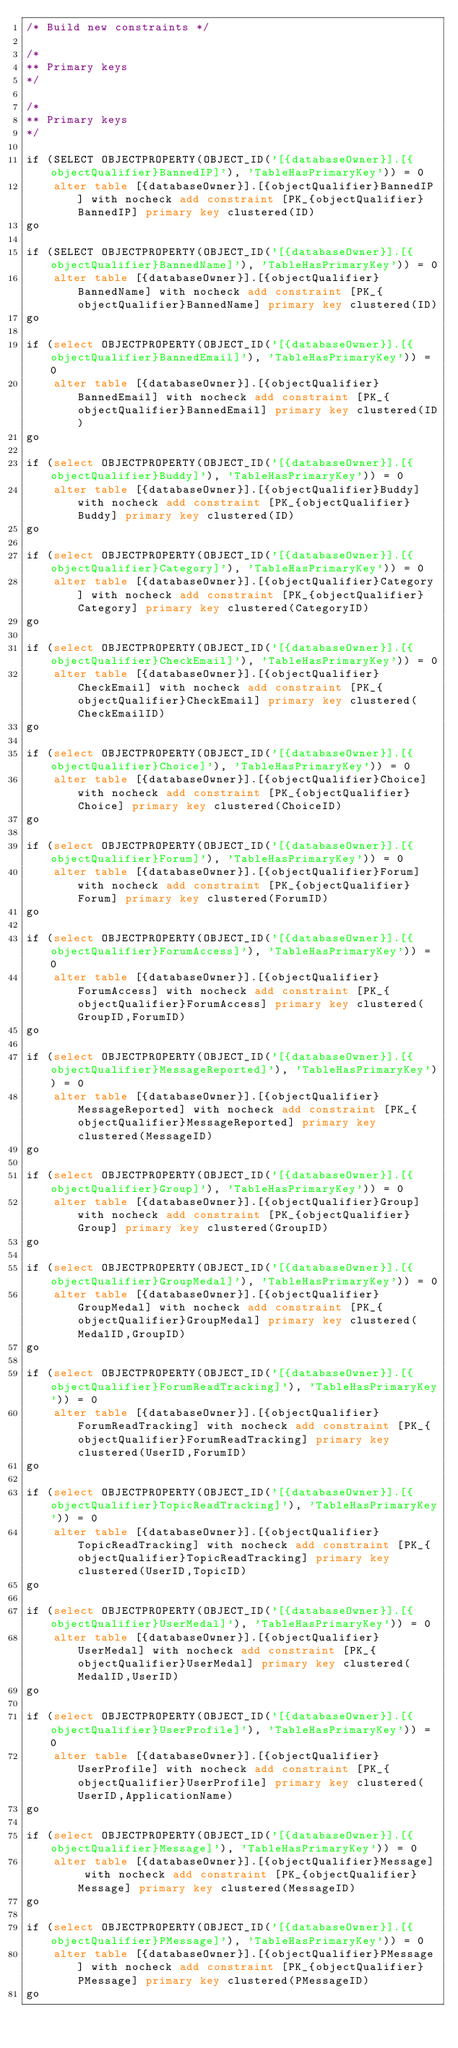Convert code to text. <code><loc_0><loc_0><loc_500><loc_500><_SQL_>/* Build new constraints */

/*
** Primary keys
*/

/*
** Primary keys
*/

if (SELECT OBJECTPROPERTY(OBJECT_ID('[{databaseOwner}].[{objectQualifier}BannedIP]'), 'TableHasPrimaryKey')) = 0
	alter table [{databaseOwner}].[{objectQualifier}BannedIP] with nocheck add constraint [PK_{objectQualifier}BannedIP] primary key clustered(ID)
go

if (SELECT OBJECTPROPERTY(OBJECT_ID('[{databaseOwner}].[{objectQualifier}BannedName]'), 'TableHasPrimaryKey')) = 0
	alter table [{databaseOwner}].[{objectQualifier}BannedName] with nocheck add constraint [PK_{objectQualifier}BannedName] primary key clustered(ID)
go

if (select OBJECTPROPERTY(OBJECT_ID('[{databaseOwner}].[{objectQualifier}BannedEmail]'), 'TableHasPrimaryKey')) = 0
	alter table [{databaseOwner}].[{objectQualifier}BannedEmail] with nocheck add constraint [PK_{objectQualifier}BannedEmail] primary key clustered(ID)
go

if (select OBJECTPROPERTY(OBJECT_ID('[{databaseOwner}].[{objectQualifier}Buddy]'), 'TableHasPrimaryKey')) = 0
	alter table [{databaseOwner}].[{objectQualifier}Buddy] with nocheck add constraint [PK_{objectQualifier}Buddy] primary key clustered(ID)   
go

if (select OBJECTPROPERTY(OBJECT_ID('[{databaseOwner}].[{objectQualifier}Category]'), 'TableHasPrimaryKey')) = 0
	alter table [{databaseOwner}].[{objectQualifier}Category] with nocheck add constraint [PK_{objectQualifier}Category] primary key clustered(CategoryID)   
go

if (select OBJECTPROPERTY(OBJECT_ID('[{databaseOwner}].[{objectQualifier}CheckEmail]'), 'TableHasPrimaryKey')) = 0
	alter table [{databaseOwner}].[{objectQualifier}CheckEmail] with nocheck add constraint [PK_{objectQualifier}CheckEmail] primary key clustered(CheckEmailID)   
go

if (select OBJECTPROPERTY(OBJECT_ID('[{databaseOwner}].[{objectQualifier}Choice]'), 'TableHasPrimaryKey')) = 0
	alter table [{databaseOwner}].[{objectQualifier}Choice] with nocheck add constraint [PK_{objectQualifier}Choice] primary key clustered(ChoiceID)   
go

if (select OBJECTPROPERTY(OBJECT_ID('[{databaseOwner}].[{objectQualifier}Forum]'), 'TableHasPrimaryKey')) = 0
	alter table [{databaseOwner}].[{objectQualifier}Forum] with nocheck add constraint [PK_{objectQualifier}Forum] primary key clustered(ForumID)   
go

if (select OBJECTPROPERTY(OBJECT_ID('[{databaseOwner}].[{objectQualifier}ForumAccess]'), 'TableHasPrimaryKey')) = 0
	alter table [{databaseOwner}].[{objectQualifier}ForumAccess] with nocheck add constraint [PK_{objectQualifier}ForumAccess] primary key clustered(GroupID,ForumID)   
go

if (select OBJECTPROPERTY(OBJECT_ID('[{databaseOwner}].[{objectQualifier}MessageReported]'), 'TableHasPrimaryKey')) = 0
	alter table [{databaseOwner}].[{objectQualifier}MessageReported] with nocheck add constraint [PK_{objectQualifier}MessageReported] primary key clustered(MessageID)   
go

if (select OBJECTPROPERTY(OBJECT_ID('[{databaseOwner}].[{objectQualifier}Group]'), 'TableHasPrimaryKey')) = 0
	alter table [{databaseOwner}].[{objectQualifier}Group] with nocheck add constraint [PK_{objectQualifier}Group] primary key clustered(GroupID)   
go

if (select OBJECTPROPERTY(OBJECT_ID('[{databaseOwner}].[{objectQualifier}GroupMedal]'), 'TableHasPrimaryKey')) = 0
	alter table [{databaseOwner}].[{objectQualifier}GroupMedal] with nocheck add constraint [PK_{objectQualifier}GroupMedal] primary key clustered(MedalID,GroupID)   
go

if (select OBJECTPROPERTY(OBJECT_ID('[{databaseOwner}].[{objectQualifier}ForumReadTracking]'), 'TableHasPrimaryKey')) = 0
	alter table [{databaseOwner}].[{objectQualifier}ForumReadTracking] with nocheck add constraint [PK_{objectQualifier}ForumReadTracking] primary key clustered(UserID,ForumID)   
go

if (select OBJECTPROPERTY(OBJECT_ID('[{databaseOwner}].[{objectQualifier}TopicReadTracking]'), 'TableHasPrimaryKey')) = 0
	alter table [{databaseOwner}].[{objectQualifier}TopicReadTracking] with nocheck add constraint [PK_{objectQualifier}TopicReadTracking] primary key clustered(UserID,TopicID)   
go

if (select OBJECTPROPERTY(OBJECT_ID('[{databaseOwner}].[{objectQualifier}UserMedal]'), 'TableHasPrimaryKey')) = 0
	alter table [{databaseOwner}].[{objectQualifier}UserMedal] with nocheck add constraint [PK_{objectQualifier}UserMedal] primary key clustered(MedalID,UserID)   
go

if (select OBJECTPROPERTY(OBJECT_ID('[{databaseOwner}].[{objectQualifier}UserProfile]'), 'TableHasPrimaryKey')) = 0
	alter table [{databaseOwner}].[{objectQualifier}UserProfile] with nocheck add constraint [PK_{objectQualifier}UserProfile] primary key clustered(UserID,ApplicationName)   
go

if (select OBJECTPROPERTY(OBJECT_ID('[{databaseOwner}].[{objectQualifier}Message]'), 'TableHasPrimaryKey')) = 0
	alter table [{databaseOwner}].[{objectQualifier}Message] with nocheck add constraint [PK_{objectQualifier}Message] primary key clustered(MessageID)   
go

if (select OBJECTPROPERTY(OBJECT_ID('[{databaseOwner}].[{objectQualifier}PMessage]'), 'TableHasPrimaryKey')) = 0
	alter table [{databaseOwner}].[{objectQualifier}PMessage] with nocheck add constraint [PK_{objectQualifier}PMessage] primary key clustered(PMessageID)   
go
</code> 